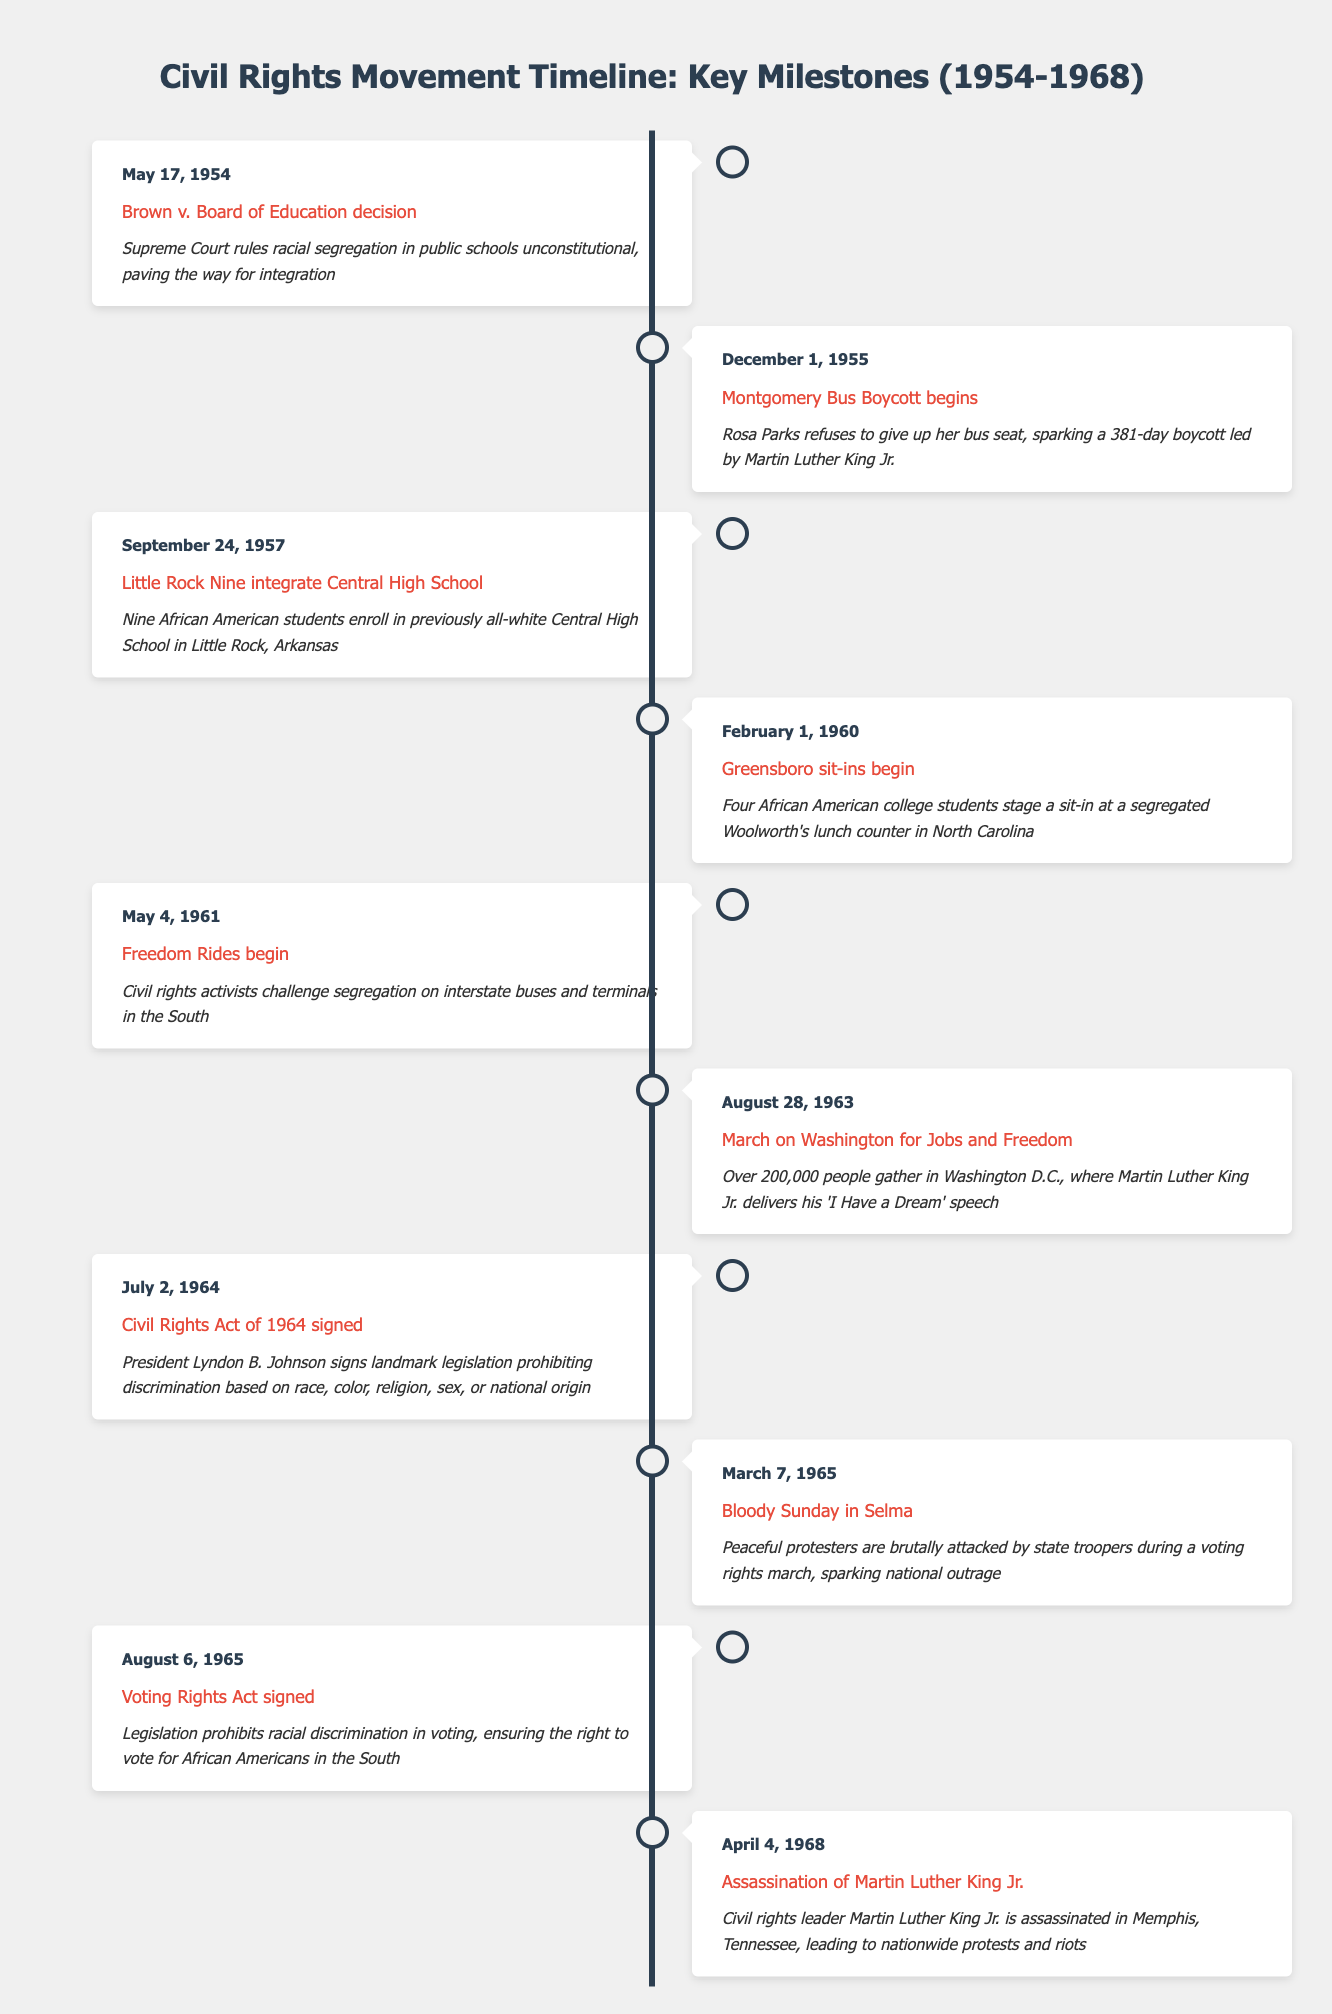What event took place on August 28, 1963? According to the timeline, the event recorded on August 28, 1963, is the "March on Washington for Jobs and Freedom."
Answer: March on Washington for Jobs and Freedom How many days did the Montgomery Bus Boycott last? The Montgomery Bus Boycott began on December 1, 1955, and lasted for 381 days. This duration is explicitly stated in the description of the corresponding event.
Answer: 381 days Was the Civil Rights Act of 1964 signed before or after the Voting Rights Act of 1965? The Civil Rights Act of 1964 was signed on July 2, 1964, while the Voting Rights Act was signed on August 6, 1965. Since July 2, 1964, is before August 6, 1965, the Civil Rights Act was signed first.
Answer: Before What is the time difference in years between the Brown v. Board of Education decision and the assassination of Martin Luther King Jr.? The Brown v. Board of Education decision occurred on May 17, 1954, and the assassination of Martin Luther King Jr. took place on April 4, 1968. The time difference is calculated by determining the years between these two dates: 1968 - 1954 = 14 years. However, since the dates don't include a full year from May 17, 1954, to April 4, 1968, the effective difference is approximately 13 years and 11 months.
Answer: Approximately 14 years Did the Greensboro sit-ins occur before the Freedom Rides? The Greensboro sit-ins began on February 1, 1960, while the Freedom Rides commenced on May 4, 1961. Since February 1, 1960, is before May 4, 1961, the Greensboro sit-ins occurred first.
Answer: Yes 